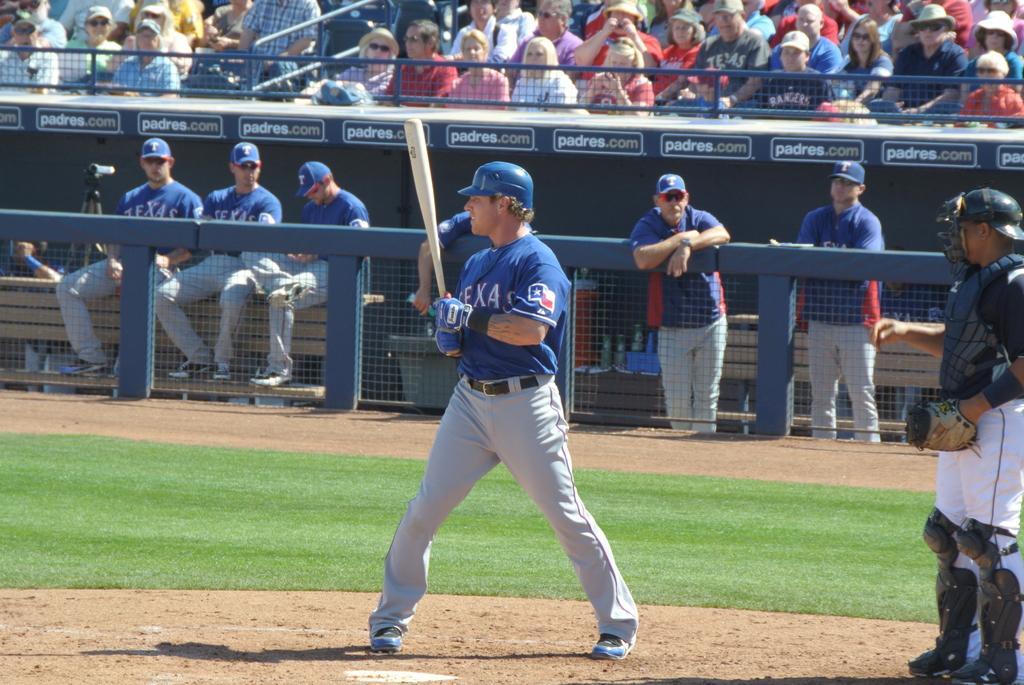Describe this image in one or two sentences. In the image I can see people among them some are standing on the ground and some are sitting. In the background I can see fence, the grass and some other objects. The person in front of the image is holding a bat and wearing a helmet. 